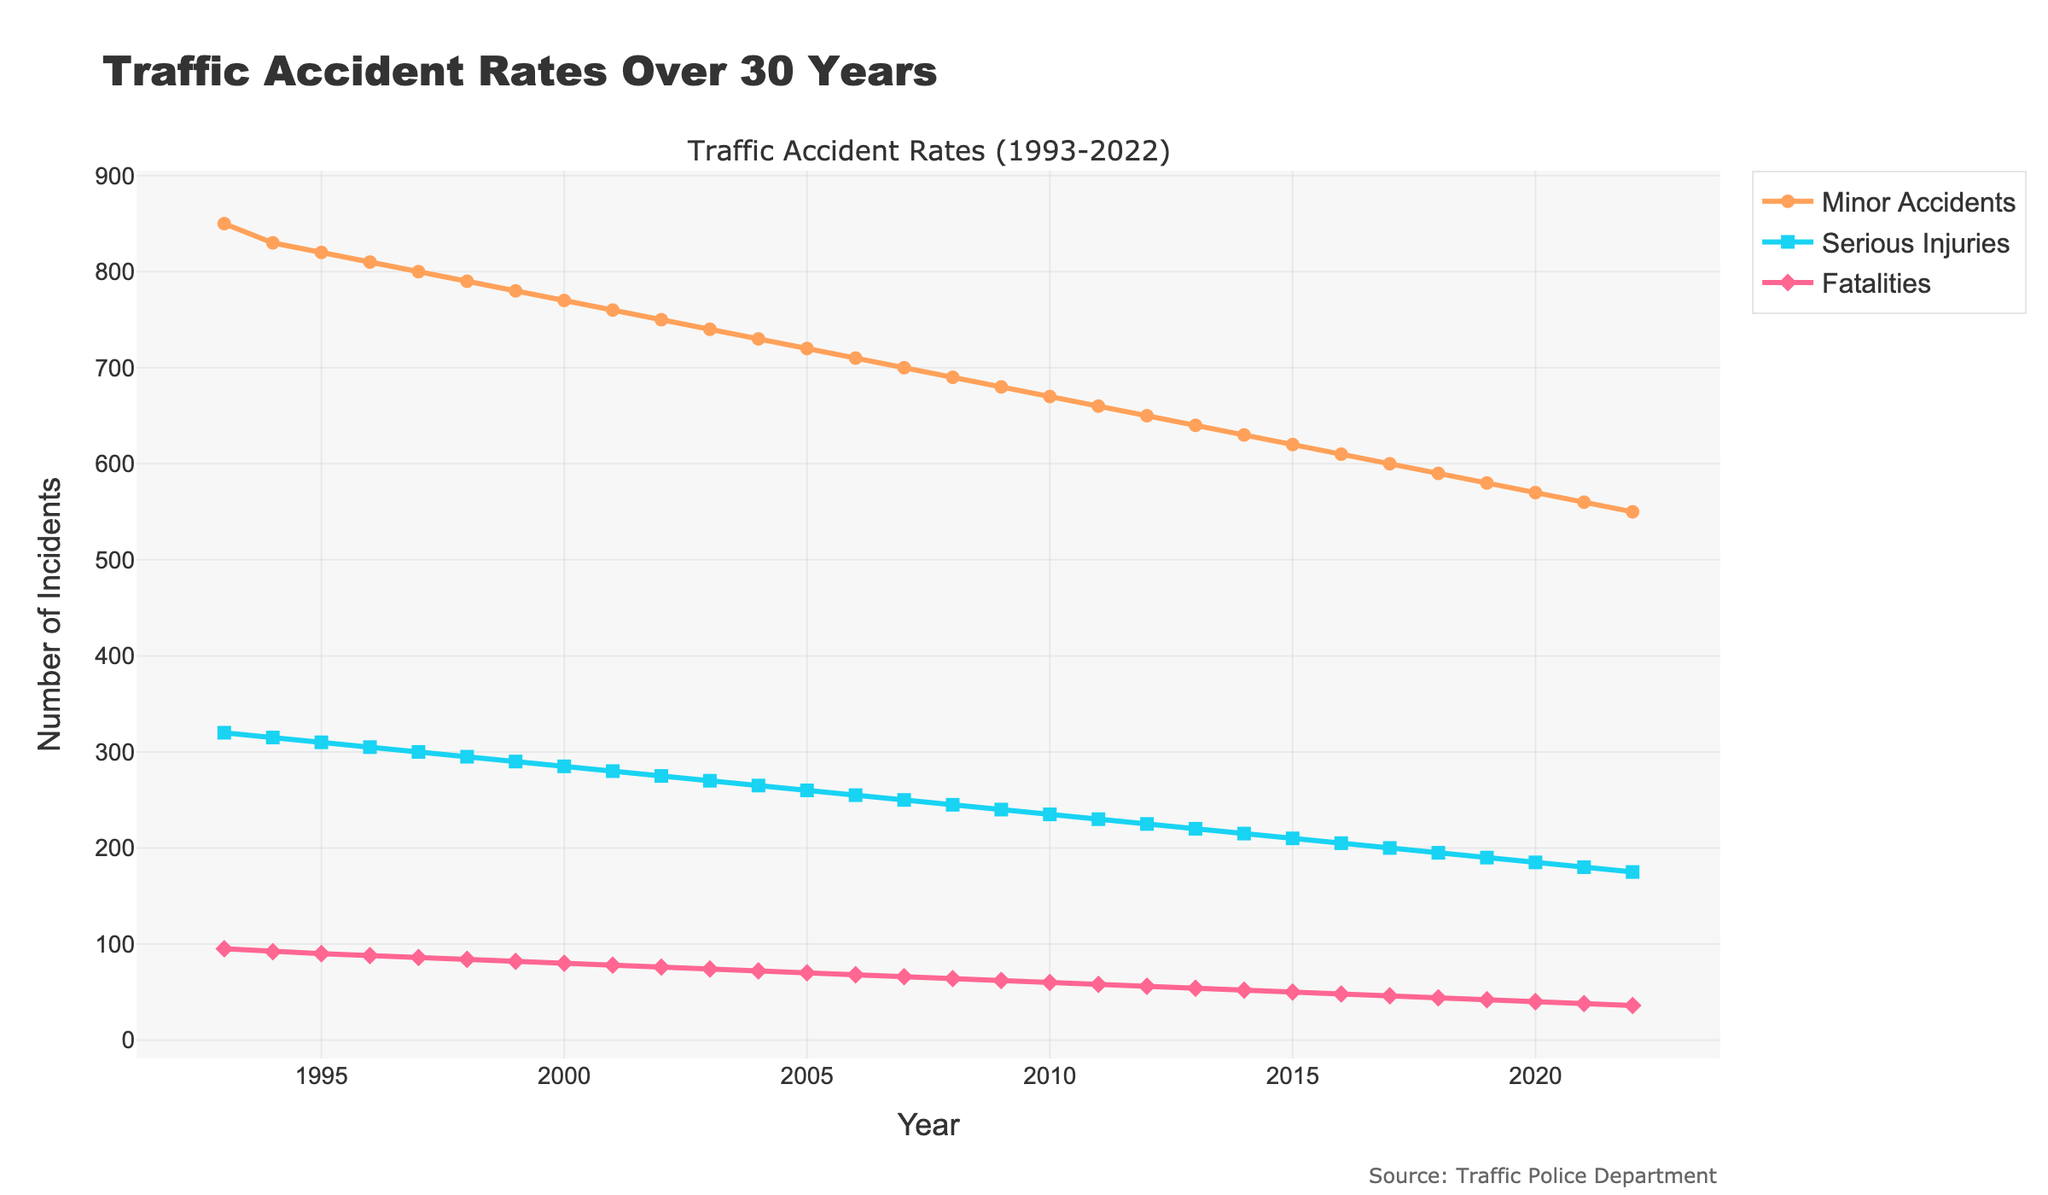Which category showed the greatest decline over the 30 years? To determine the category with the greatest decline, we need to calculate the difference between the earliest and latest values for each category. Minor Accidents declined from 850 to 550 (300 decline), Serious Injuries declined from 320 to 175 (145 decline), and Fatalities declined from 95 to 36 (59 decline). Comparing these values, Minor Accidents has the greatest decline.
Answer: Minor Accidents Between which two consecutive years did Fatalities show the greatest drop? To identify the largest drop, look at the changes in Fatalities from one year to the next. The data shows the largest yearly decline in Fatalities occurred between 1993 (95) and 1994 (92), a drop of 3. No other consecutive years show a larger drop.
Answer: Between 1993 and 1994 Are there any years where two categories have the same number of incidents or close to it? Scan the lines for overlapping points or close values in the three categories. In 1998, Serious Injuries (295) and Minor Accidents (290) have very close values, but they are not the same. The closest comparable incidence values are generally separated by different values.
Answer: No exact match, closest in 1998 Which year had the highest number of total incidents across all categories? Sum the incidents for each year across all categories. E.g., for 1993: 850 (Minor) + 320 (Serious) + 95 (Fatalities) = 1265. Repeating for all years, the highest sum is in 1993, the total is 1265.
Answer: 1993 What is the average number of Minor Accidents over the entire period? First, sum up the values of Minor Accidents from 1993 to 2022. The sum is 850 + 830 + 820 + ... + 550. Then, divide this sum by 30 (number of years). (Sum = 21,000, Average = 21,000 / 30)
Answer: 700 In which year did Minor Accidents fall below 600 for the first time? Scan the data points for Minor Accidents from 1993 onwards until you see a value below 600. The first instance is in 2017, where Minor Accidents are recorded as 590.
Answer: 2017 How did the trend of Serious Injuries change over the 30 years? Observe and describe the overall visual trend. Serious Injuries consistently decrease from 320 in 1993 to 175 in 2022, indicating a steady downward trend.
Answer: Downward trend Compare the rate of decrease in Serious Injuries to Fatalities. Which decreased more rapidly? Calculate the percentage decrease for each. Serious Injuries decreased from 320 to 175 (approximately 45.31%), while Fatalities decreased from 95 to 36 (approximately 62.11%). Fatalities decreased more rapidly.
Answer: Fatalities Which color represents the Fatalities category in the plot? Look at the legend or the line color associated with Fatalities. The Fatalities line in the plot is colored in red.
Answer: Red 